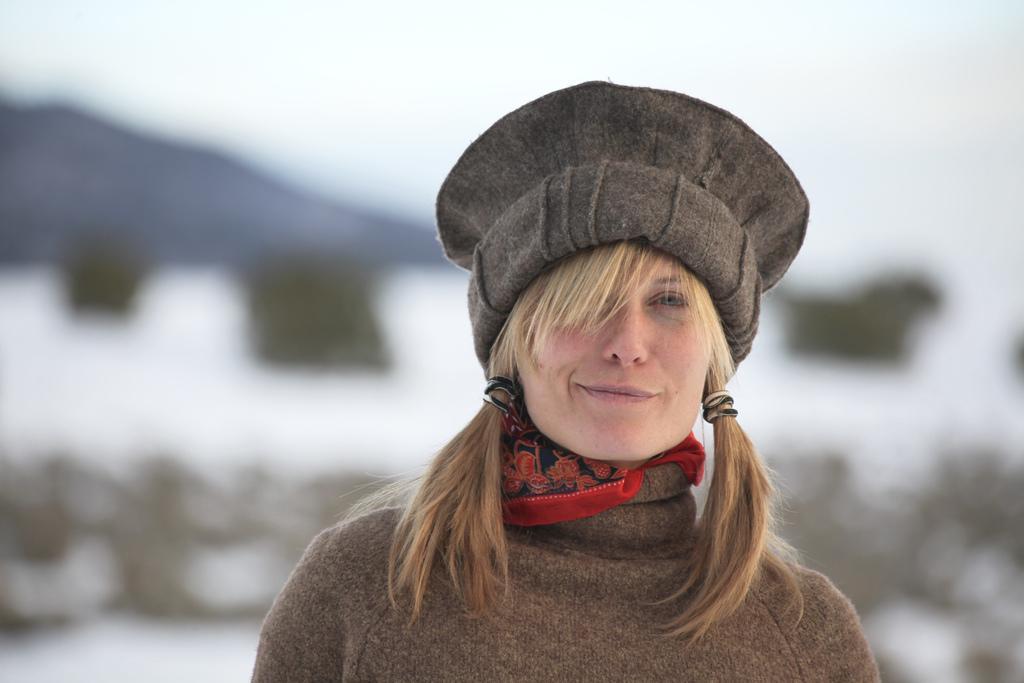Please provide a concise description of this image. In the foreground I can see a woman is wearing a hat. In the background I can see the sky. This image is taken during a day. 